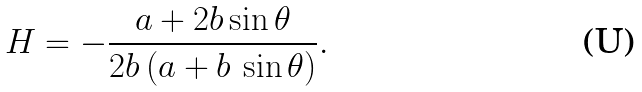<formula> <loc_0><loc_0><loc_500><loc_500>H = - \frac { a + 2 b \sin \theta } { 2 b \, { \left ( a + b \, \sin \theta \right ) } } .</formula> 